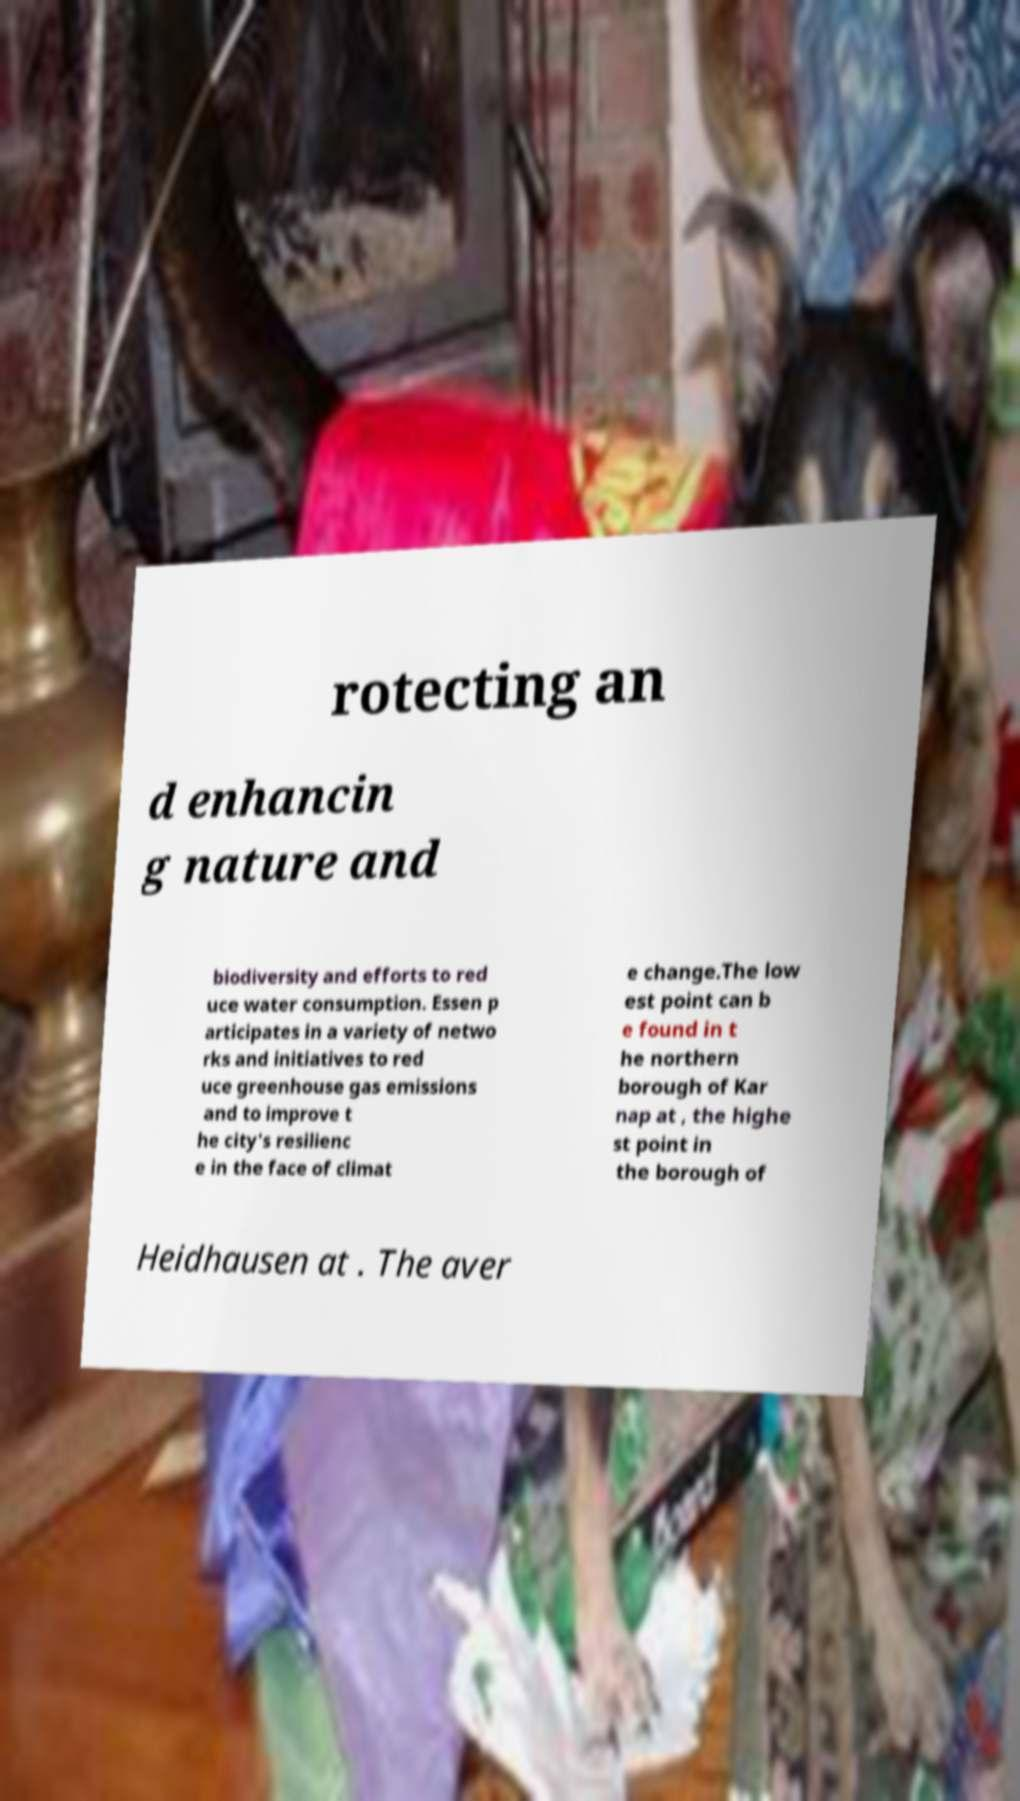Could you assist in decoding the text presented in this image and type it out clearly? rotecting an d enhancin g nature and biodiversity and efforts to red uce water consumption. Essen p articipates in a variety of netwo rks and initiatives to red uce greenhouse gas emissions and to improve t he city's resilienc e in the face of climat e change.The low est point can b e found in t he northern borough of Kar nap at , the highe st point in the borough of Heidhausen at . The aver 